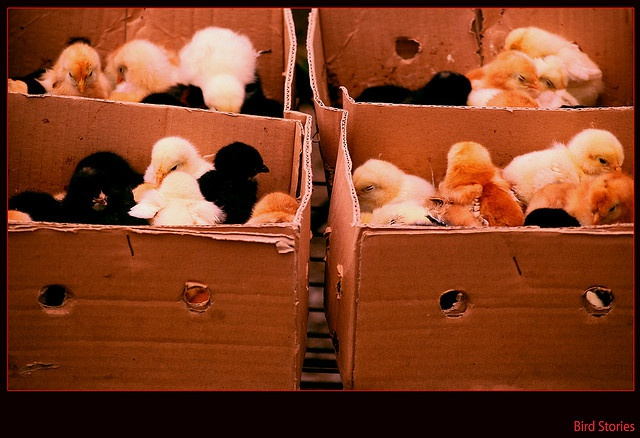Describe the objects in this image and their specific colors. I can see bird in black, maroon, salmon, and red tones, bird in black, tan, lightgray, and lightpink tones, bird in black, lightgray, tan, lightpink, and salmon tones, bird in black, salmon, tan, and brown tones, and bird in black, tan, and red tones in this image. 